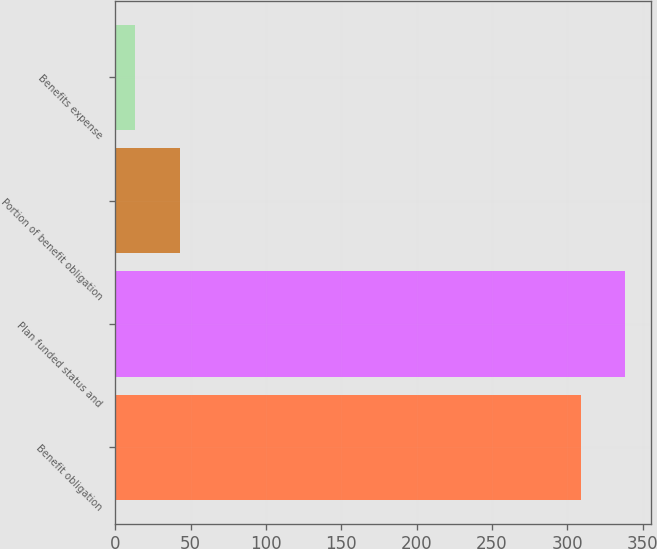Convert chart. <chart><loc_0><loc_0><loc_500><loc_500><bar_chart><fcel>Benefit obligation<fcel>Plan funded status and<fcel>Portion of benefit obligation<fcel>Benefits expense<nl><fcel>309<fcel>338.6<fcel>42.6<fcel>13<nl></chart> 